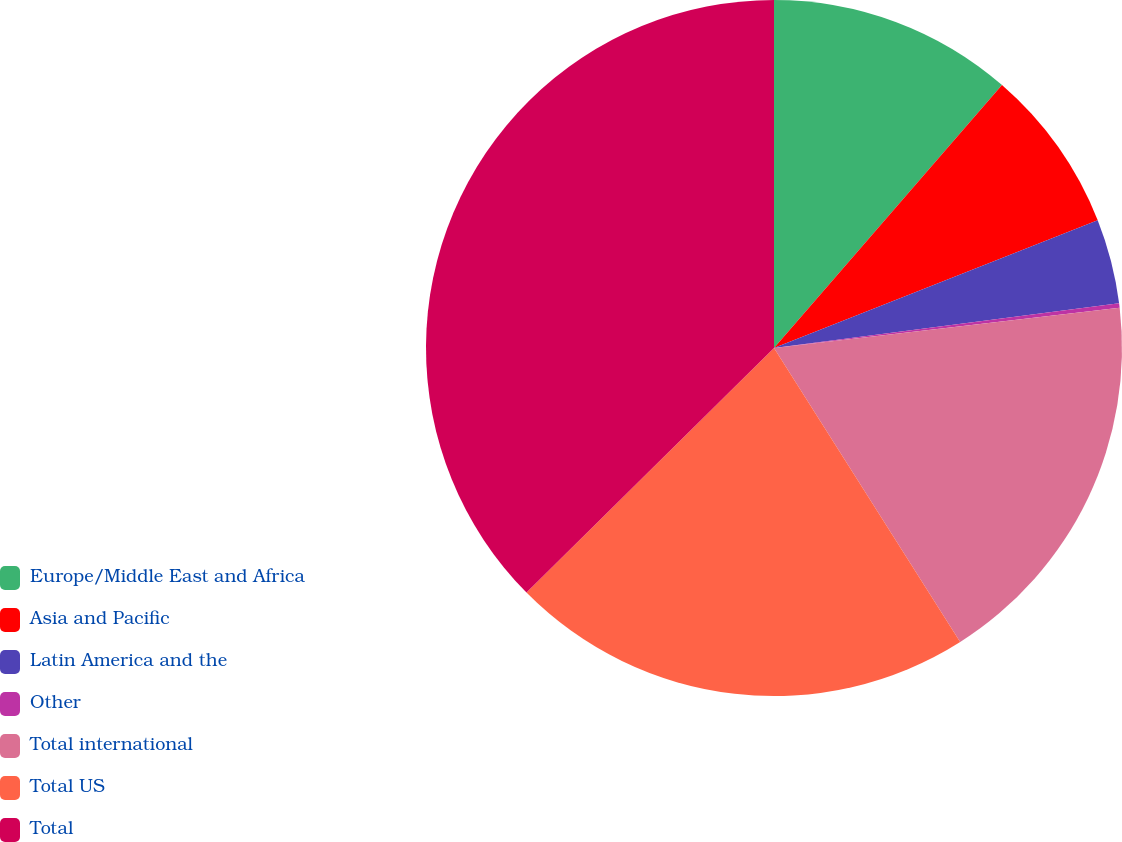<chart> <loc_0><loc_0><loc_500><loc_500><pie_chart><fcel>Europe/Middle East and Africa<fcel>Asia and Pacific<fcel>Latin America and the<fcel>Other<fcel>Total international<fcel>Total US<fcel>Total<nl><fcel>11.37%<fcel>7.65%<fcel>3.93%<fcel>0.21%<fcel>17.86%<fcel>21.58%<fcel>37.41%<nl></chart> 